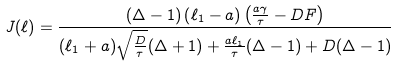<formula> <loc_0><loc_0><loc_500><loc_500>J ( \ell ) = \frac { \left ( \Delta - 1 \right ) \left ( \ell _ { 1 } - a \right ) \left ( \frac { a \gamma } { \tau } - D F \right ) } { ( \ell _ { 1 } + a ) \sqrt { \frac { D } { \tau } } ( \Delta + 1 ) + \frac { a \ell _ { 1 } } { \tau } ( \Delta - 1 ) + D ( \Delta - 1 ) }</formula> 